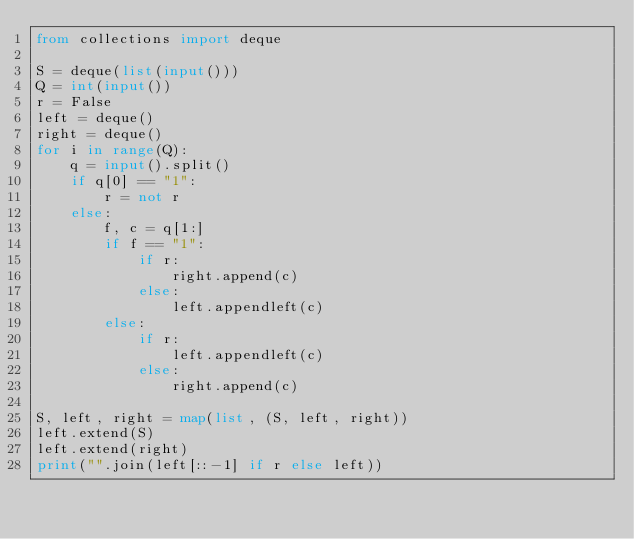<code> <loc_0><loc_0><loc_500><loc_500><_Python_>from collections import deque

S = deque(list(input()))
Q = int(input())
r = False
left = deque()
right = deque()
for i in range(Q):
    q = input().split()
    if q[0] == "1":
        r = not r
    else:
        f, c = q[1:]
        if f == "1":
            if r:
                right.append(c)
            else:
                left.appendleft(c)
        else:
            if r:
                left.appendleft(c)
            else:
                right.append(c)

S, left, right = map(list, (S, left, right))
left.extend(S)
left.extend(right)
print("".join(left[::-1] if r else left))</code> 